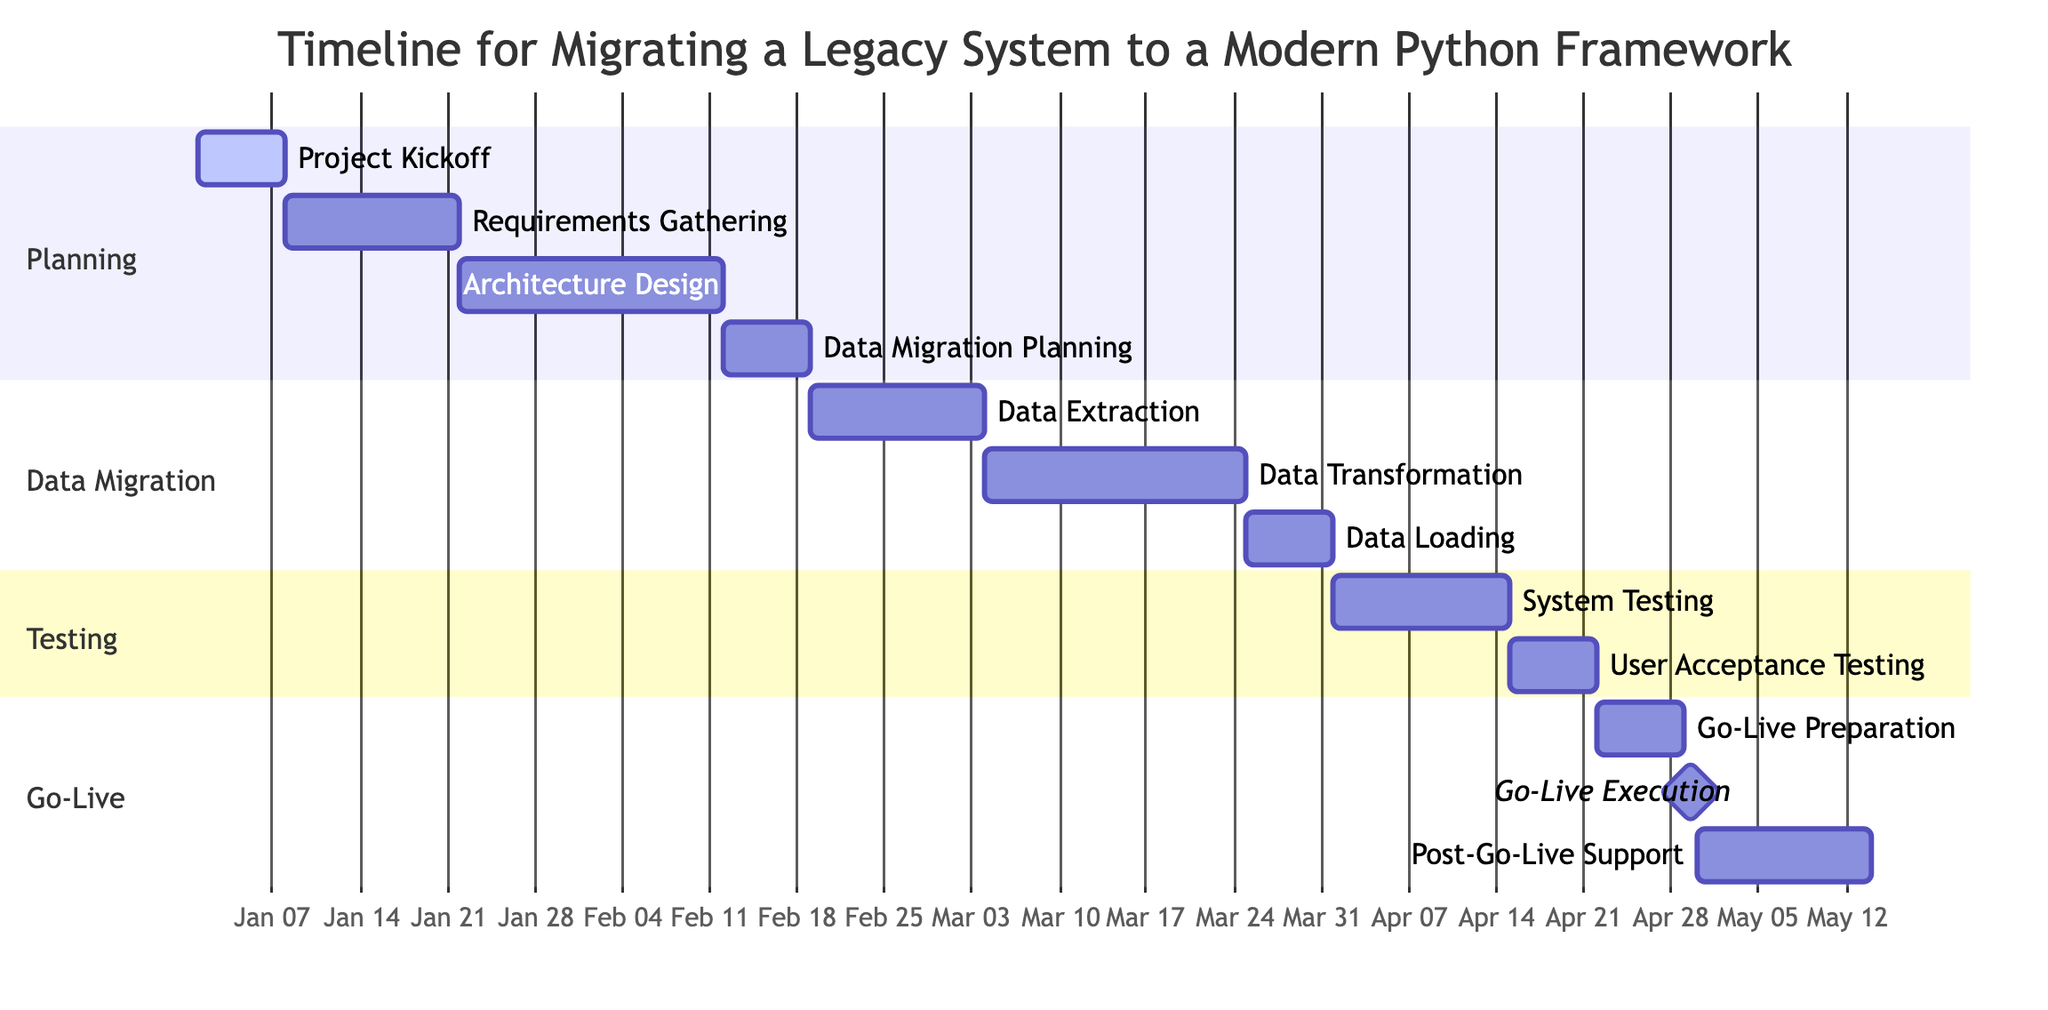What is the duration of the 'Go-Live Preparation' stage? The duration of 'Go-Live Preparation' is indicated directly in the Gantt Chart, where it is listed as '1 week.'
Answer: 1 week What date does 'Data Loading into New System' start? The start date of 'Data Loading into New System' is shown clearly in the diagram as '2024-03-25.'
Answer: 2024-03-25 Which stage has the longest duration? To determine which stage has the longest duration, we need to review the duration of all stages. 'Data Transformation and Cleanup' lasts for 3 weeks, which is longer than any other stage.
Answer: Data Transformation and Cleanup How many weeks are allocated for 'User Acceptance Testing'? The Gantt chart states that 'User Acceptance Testing' lasts for '1 week.'
Answer: 1 week Which sections contain stages related to testing? In the Gantt Chart, the sections named 'Testing' contain stages specifically related to testing. These include 'System Testing' and 'User Acceptance Testing.'
Answer: Testing What stage immediately follows 'Data Migration Planning'? By examining the chart, we can see that 'Data Extraction from Legacy System' follows 'Data Migration Planning' and starts on '2024-02-19.'
Answer: Data Extraction from Legacy System When does the 'Go-Live Execution' occur? The diagram specifically lists 'Go-Live Execution' with a date of '2024-04-29.'
Answer: 2024-04-29 How many stages have a duration of 1 week? In the Gantt Chart, by examining the durations, we can identify three stages that have a duration of 1 week: 'Project Kickoff', 'Data Loading into New System', and 'Go-Live Preparation.'
Answer: 3 What is the total duration of all phases if we combine them? To find the total duration of all phases, we sum the durations of each stage: 1+2+3+1+2+3+1+2+1+1+2 = 19 weeks total across different activities.
Answer: 19 weeks 